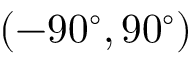<formula> <loc_0><loc_0><loc_500><loc_500>( - 9 0 ^ { \circ } , 9 0 ^ { \circ } )</formula> 